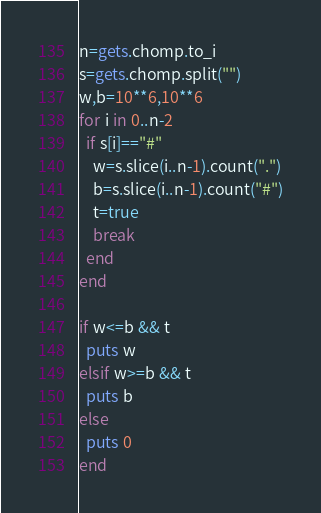Convert code to text. <code><loc_0><loc_0><loc_500><loc_500><_Ruby_>n=gets.chomp.to_i
s=gets.chomp.split("")
w,b=10**6,10**6
for i in 0..n-2
  if s[i]=="#"
    w=s.slice(i..n-1).count(".")
    b=s.slice(i..n-1).count("#")
    t=true
    break
  end
end

if w<=b && t
  puts w
elsif w>=b && t
  puts b
else
  puts 0
end</code> 